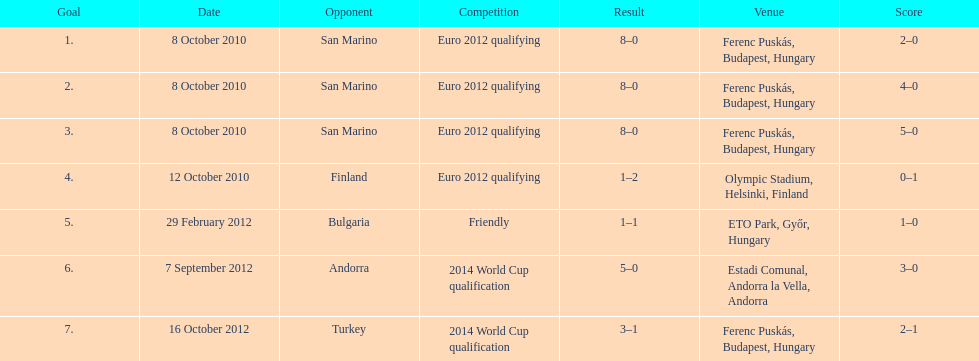What is the count of goals ádám szalai netted against san marino in 2010? 3. 